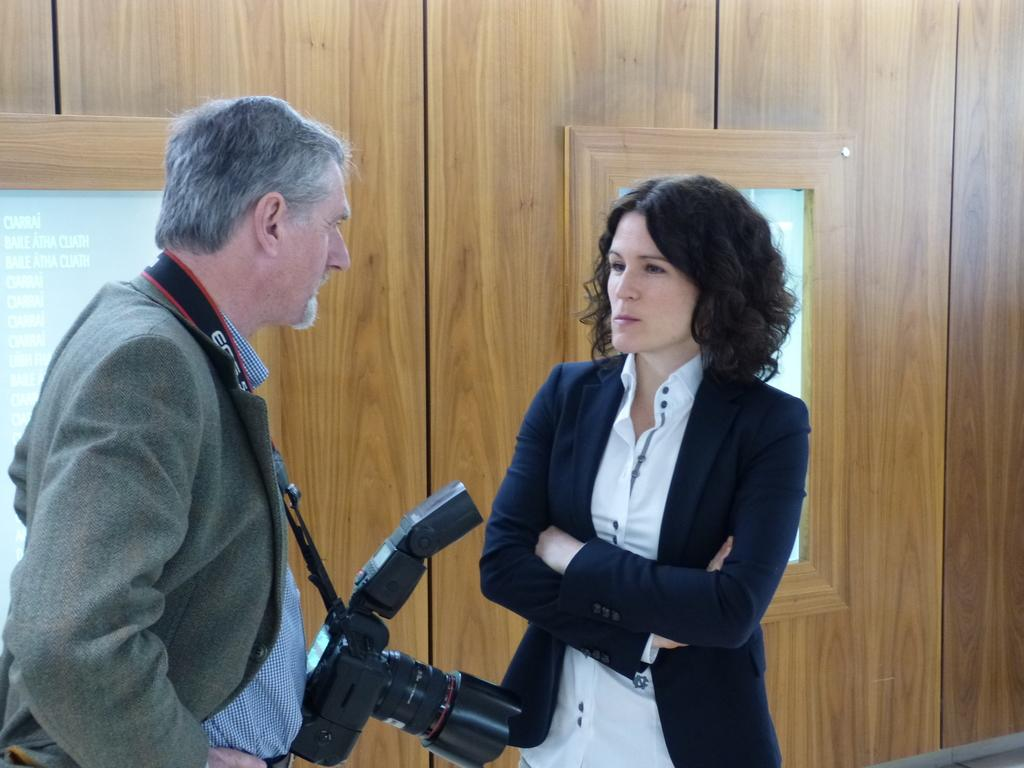How many people are in the image? There are two people standing in the image. Can you describe one of the people? One of the people is a man. What is the man holding in the image? The man is carrying a camera. What can be seen in the background of the image? There are boards on a wooden wall in the background of the image. Where is the cow located in the image? There is no cow present in the image. What type of house can be seen in the background of the image? There is no house visible in the image; only boards on a wooden wall are present in the background. 